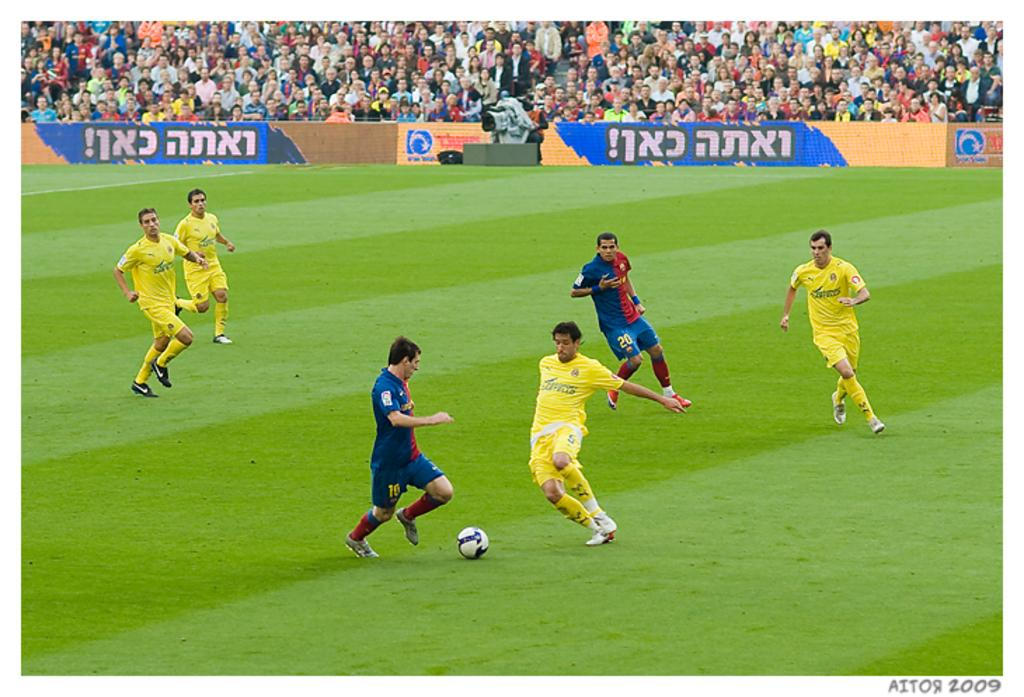<image>
Summarize the visual content of the image. Teams play soccer on a field, some of the uniforms are red and blue and one has the number 20 on his shorts. 